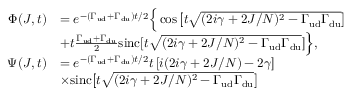<formula> <loc_0><loc_0><loc_500><loc_500>\begin{array} { r l } { \Phi ( J , t ) } & { = e ^ { - \left ( \Gamma _ { u d } + \Gamma _ { d u } \right ) t / 2 } \left \{ \cos \left [ t \sqrt { ( 2 i \gamma + 2 J / N ) ^ { 2 } - \Gamma _ { u d } \Gamma _ { d u } } \right ] } \\ & { + t \frac { \Gamma _ { u d } + \Gamma _ { d u } } { 2 } \sin c [ t \sqrt { ( 2 i \gamma + 2 J / N ) ^ { 2 } - \Gamma _ { u d } \Gamma _ { d u } } ] \right \} , } \\ { \Psi ( J , t ) } & { = e ^ { - \left ( \Gamma _ { u d } + \Gamma _ { d u } \right ) t / 2 } t \left [ i ( 2 i \gamma + 2 J / N ) - 2 \gamma \right ] } \\ & { \times \sin c \left [ t \sqrt { ( 2 i \gamma + 2 J / N ) ^ { 2 } - \Gamma _ { u d } \Gamma _ { d u } } \right ] } \end{array}</formula> 